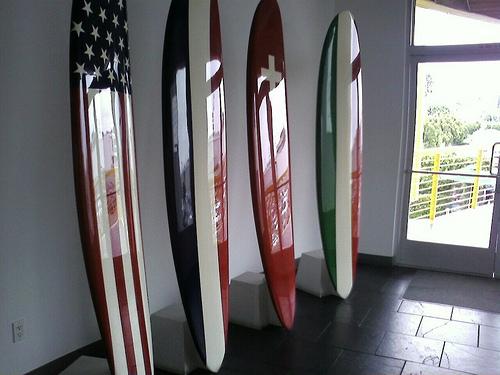Which country represented is not in Europe?
Write a very short answer. Usa. What colors are on all 4 boards?
Short answer required. Red and white. How many surfboards are stored?
Answer briefly. 4. What is the number of surfboards?
Be succinct. 4. How many surfboards are there?
Give a very brief answer. 4. Are these patterns also on flags?
Be succinct. Yes. How many boards are there?
Quick response, please. 4. What number of surfboards are in this image?
Concise answer only. 4. What are these?
Short answer required. Surfboards. 